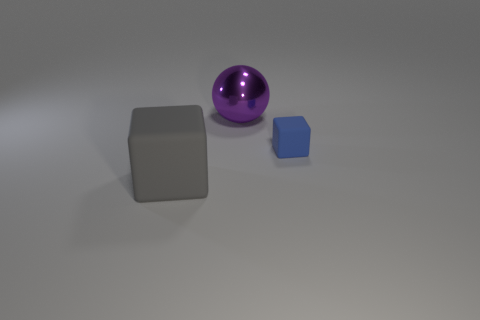Can you describe the lighting in the scene? The lighting appears to be soft and diffused, coming from above, casting gentle shadows beneath the objects, which suggests an indoor setting with ambient lighting. 